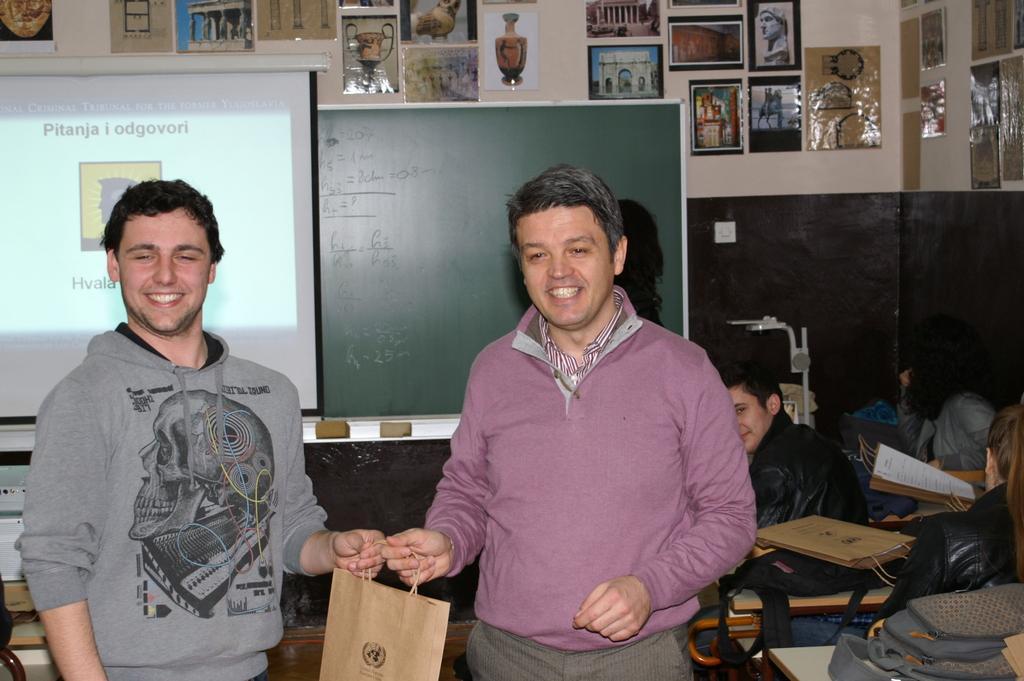How would you summarize this image in a sentence or two? In this image in the center there are two people who are standing, and they are holding a bag and on the right side of the image there are some people who are sitting on benches. And on the benches there are some bags and papers, and in the background there is a screen, board and some posters on the wall and objects. 